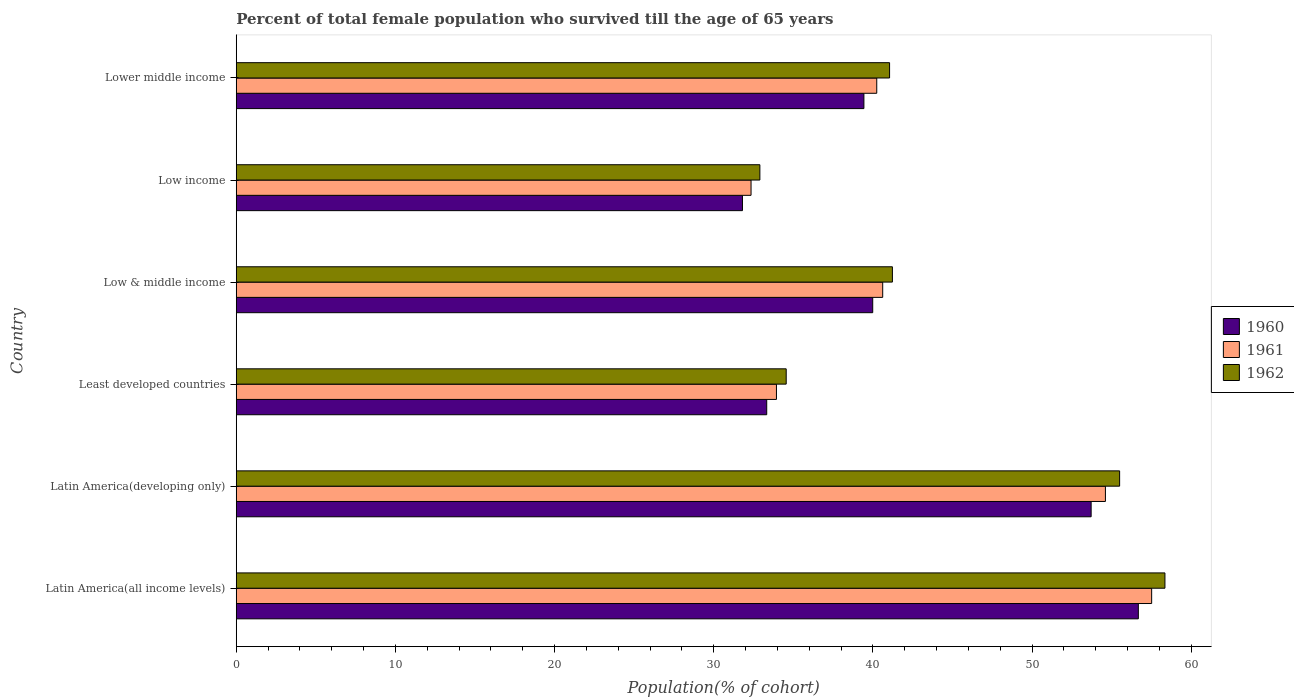How many groups of bars are there?
Provide a succinct answer. 6. Are the number of bars per tick equal to the number of legend labels?
Your answer should be very brief. Yes. How many bars are there on the 4th tick from the top?
Offer a very short reply. 3. How many bars are there on the 3rd tick from the bottom?
Provide a short and direct response. 3. What is the label of the 6th group of bars from the top?
Offer a terse response. Latin America(all income levels). What is the percentage of total female population who survived till the age of 65 years in 1960 in Latin America(developing only)?
Keep it short and to the point. 53.71. Across all countries, what is the maximum percentage of total female population who survived till the age of 65 years in 1962?
Provide a short and direct response. 58.34. Across all countries, what is the minimum percentage of total female population who survived till the age of 65 years in 1960?
Keep it short and to the point. 31.8. In which country was the percentage of total female population who survived till the age of 65 years in 1961 maximum?
Your answer should be very brief. Latin America(all income levels). In which country was the percentage of total female population who survived till the age of 65 years in 1961 minimum?
Make the answer very short. Low income. What is the total percentage of total female population who survived till the age of 65 years in 1962 in the graph?
Your answer should be very brief. 263.55. What is the difference between the percentage of total female population who survived till the age of 65 years in 1962 in Low & middle income and that in Lower middle income?
Your answer should be very brief. 0.18. What is the difference between the percentage of total female population who survived till the age of 65 years in 1961 in Latin America(developing only) and the percentage of total female population who survived till the age of 65 years in 1960 in Low income?
Make the answer very short. 22.8. What is the average percentage of total female population who survived till the age of 65 years in 1960 per country?
Provide a succinct answer. 42.49. What is the difference between the percentage of total female population who survived till the age of 65 years in 1960 and percentage of total female population who survived till the age of 65 years in 1962 in Least developed countries?
Give a very brief answer. -1.22. In how many countries, is the percentage of total female population who survived till the age of 65 years in 1962 greater than 56 %?
Your answer should be very brief. 1. What is the ratio of the percentage of total female population who survived till the age of 65 years in 1961 in Latin America(developing only) to that in Least developed countries?
Ensure brevity in your answer.  1.61. Is the percentage of total female population who survived till the age of 65 years in 1960 in Latin America(developing only) less than that in Low income?
Give a very brief answer. No. What is the difference between the highest and the second highest percentage of total female population who survived till the age of 65 years in 1960?
Make the answer very short. 2.97. What is the difference between the highest and the lowest percentage of total female population who survived till the age of 65 years in 1961?
Ensure brevity in your answer.  25.17. In how many countries, is the percentage of total female population who survived till the age of 65 years in 1961 greater than the average percentage of total female population who survived till the age of 65 years in 1961 taken over all countries?
Provide a succinct answer. 2. Is the sum of the percentage of total female population who survived till the age of 65 years in 1961 in Latin America(all income levels) and Latin America(developing only) greater than the maximum percentage of total female population who survived till the age of 65 years in 1960 across all countries?
Provide a succinct answer. Yes. Is it the case that in every country, the sum of the percentage of total female population who survived till the age of 65 years in 1962 and percentage of total female population who survived till the age of 65 years in 1960 is greater than the percentage of total female population who survived till the age of 65 years in 1961?
Provide a succinct answer. Yes. How many bars are there?
Your answer should be compact. 18. Are all the bars in the graph horizontal?
Give a very brief answer. Yes. How many countries are there in the graph?
Your response must be concise. 6. What is the difference between two consecutive major ticks on the X-axis?
Keep it short and to the point. 10. Are the values on the major ticks of X-axis written in scientific E-notation?
Your answer should be very brief. No. Does the graph contain any zero values?
Make the answer very short. No. How many legend labels are there?
Offer a terse response. 3. How are the legend labels stacked?
Offer a terse response. Vertical. What is the title of the graph?
Your response must be concise. Percent of total female population who survived till the age of 65 years. What is the label or title of the X-axis?
Offer a terse response. Population(% of cohort). What is the label or title of the Y-axis?
Provide a succinct answer. Country. What is the Population(% of cohort) of 1960 in Latin America(all income levels)?
Your answer should be compact. 56.67. What is the Population(% of cohort) in 1961 in Latin America(all income levels)?
Ensure brevity in your answer.  57.51. What is the Population(% of cohort) of 1962 in Latin America(all income levels)?
Your answer should be very brief. 58.34. What is the Population(% of cohort) in 1960 in Latin America(developing only)?
Offer a very short reply. 53.71. What is the Population(% of cohort) of 1961 in Latin America(developing only)?
Keep it short and to the point. 54.6. What is the Population(% of cohort) in 1962 in Latin America(developing only)?
Your answer should be compact. 55.5. What is the Population(% of cohort) in 1960 in Least developed countries?
Give a very brief answer. 33.33. What is the Population(% of cohort) of 1961 in Least developed countries?
Offer a very short reply. 33.94. What is the Population(% of cohort) in 1962 in Least developed countries?
Ensure brevity in your answer.  34.55. What is the Population(% of cohort) of 1960 in Low & middle income?
Keep it short and to the point. 39.98. What is the Population(% of cohort) in 1961 in Low & middle income?
Make the answer very short. 40.61. What is the Population(% of cohort) in 1962 in Low & middle income?
Keep it short and to the point. 41.22. What is the Population(% of cohort) in 1960 in Low income?
Ensure brevity in your answer.  31.8. What is the Population(% of cohort) in 1961 in Low income?
Ensure brevity in your answer.  32.34. What is the Population(% of cohort) of 1962 in Low income?
Your response must be concise. 32.9. What is the Population(% of cohort) in 1960 in Lower middle income?
Offer a terse response. 39.43. What is the Population(% of cohort) in 1961 in Lower middle income?
Your response must be concise. 40.24. What is the Population(% of cohort) in 1962 in Lower middle income?
Provide a short and direct response. 41.04. Across all countries, what is the maximum Population(% of cohort) of 1960?
Your answer should be compact. 56.67. Across all countries, what is the maximum Population(% of cohort) in 1961?
Provide a succinct answer. 57.51. Across all countries, what is the maximum Population(% of cohort) in 1962?
Provide a short and direct response. 58.34. Across all countries, what is the minimum Population(% of cohort) of 1960?
Provide a short and direct response. 31.8. Across all countries, what is the minimum Population(% of cohort) in 1961?
Your response must be concise. 32.34. Across all countries, what is the minimum Population(% of cohort) of 1962?
Ensure brevity in your answer.  32.9. What is the total Population(% of cohort) of 1960 in the graph?
Keep it short and to the point. 254.92. What is the total Population(% of cohort) in 1961 in the graph?
Provide a succinct answer. 259.24. What is the total Population(% of cohort) of 1962 in the graph?
Offer a terse response. 263.55. What is the difference between the Population(% of cohort) in 1960 in Latin America(all income levels) and that in Latin America(developing only)?
Keep it short and to the point. 2.97. What is the difference between the Population(% of cohort) in 1961 in Latin America(all income levels) and that in Latin America(developing only)?
Ensure brevity in your answer.  2.9. What is the difference between the Population(% of cohort) of 1962 in Latin America(all income levels) and that in Latin America(developing only)?
Your response must be concise. 2.85. What is the difference between the Population(% of cohort) of 1960 in Latin America(all income levels) and that in Least developed countries?
Give a very brief answer. 23.35. What is the difference between the Population(% of cohort) in 1961 in Latin America(all income levels) and that in Least developed countries?
Provide a short and direct response. 23.57. What is the difference between the Population(% of cohort) in 1962 in Latin America(all income levels) and that in Least developed countries?
Give a very brief answer. 23.79. What is the difference between the Population(% of cohort) in 1960 in Latin America(all income levels) and that in Low & middle income?
Keep it short and to the point. 16.69. What is the difference between the Population(% of cohort) in 1961 in Latin America(all income levels) and that in Low & middle income?
Ensure brevity in your answer.  16.9. What is the difference between the Population(% of cohort) in 1962 in Latin America(all income levels) and that in Low & middle income?
Provide a succinct answer. 17.12. What is the difference between the Population(% of cohort) of 1960 in Latin America(all income levels) and that in Low income?
Provide a short and direct response. 24.87. What is the difference between the Population(% of cohort) in 1961 in Latin America(all income levels) and that in Low income?
Ensure brevity in your answer.  25.17. What is the difference between the Population(% of cohort) in 1962 in Latin America(all income levels) and that in Low income?
Your response must be concise. 25.45. What is the difference between the Population(% of cohort) in 1960 in Latin America(all income levels) and that in Lower middle income?
Give a very brief answer. 17.24. What is the difference between the Population(% of cohort) in 1961 in Latin America(all income levels) and that in Lower middle income?
Your answer should be compact. 17.27. What is the difference between the Population(% of cohort) of 1962 in Latin America(all income levels) and that in Lower middle income?
Provide a short and direct response. 17.3. What is the difference between the Population(% of cohort) in 1960 in Latin America(developing only) and that in Least developed countries?
Offer a very short reply. 20.38. What is the difference between the Population(% of cohort) of 1961 in Latin America(developing only) and that in Least developed countries?
Keep it short and to the point. 20.67. What is the difference between the Population(% of cohort) of 1962 in Latin America(developing only) and that in Least developed countries?
Make the answer very short. 20.95. What is the difference between the Population(% of cohort) in 1960 in Latin America(developing only) and that in Low & middle income?
Give a very brief answer. 13.72. What is the difference between the Population(% of cohort) in 1961 in Latin America(developing only) and that in Low & middle income?
Your answer should be very brief. 13.99. What is the difference between the Population(% of cohort) in 1962 in Latin America(developing only) and that in Low & middle income?
Provide a succinct answer. 14.27. What is the difference between the Population(% of cohort) in 1960 in Latin America(developing only) and that in Low income?
Provide a succinct answer. 21.9. What is the difference between the Population(% of cohort) in 1961 in Latin America(developing only) and that in Low income?
Make the answer very short. 22.26. What is the difference between the Population(% of cohort) of 1962 in Latin America(developing only) and that in Low income?
Offer a terse response. 22.6. What is the difference between the Population(% of cohort) of 1960 in Latin America(developing only) and that in Lower middle income?
Your answer should be very brief. 14.27. What is the difference between the Population(% of cohort) of 1961 in Latin America(developing only) and that in Lower middle income?
Provide a short and direct response. 14.37. What is the difference between the Population(% of cohort) of 1962 in Latin America(developing only) and that in Lower middle income?
Your answer should be very brief. 14.45. What is the difference between the Population(% of cohort) in 1960 in Least developed countries and that in Low & middle income?
Your response must be concise. -6.66. What is the difference between the Population(% of cohort) of 1961 in Least developed countries and that in Low & middle income?
Offer a very short reply. -6.67. What is the difference between the Population(% of cohort) in 1962 in Least developed countries and that in Low & middle income?
Ensure brevity in your answer.  -6.67. What is the difference between the Population(% of cohort) in 1960 in Least developed countries and that in Low income?
Offer a very short reply. 1.52. What is the difference between the Population(% of cohort) of 1961 in Least developed countries and that in Low income?
Give a very brief answer. 1.6. What is the difference between the Population(% of cohort) of 1962 in Least developed countries and that in Low income?
Provide a succinct answer. 1.65. What is the difference between the Population(% of cohort) in 1960 in Least developed countries and that in Lower middle income?
Offer a terse response. -6.11. What is the difference between the Population(% of cohort) in 1961 in Least developed countries and that in Lower middle income?
Keep it short and to the point. -6.3. What is the difference between the Population(% of cohort) of 1962 in Least developed countries and that in Lower middle income?
Your response must be concise. -6.49. What is the difference between the Population(% of cohort) in 1960 in Low & middle income and that in Low income?
Your answer should be compact. 8.18. What is the difference between the Population(% of cohort) in 1961 in Low & middle income and that in Low income?
Ensure brevity in your answer.  8.27. What is the difference between the Population(% of cohort) in 1962 in Low & middle income and that in Low income?
Your answer should be very brief. 8.33. What is the difference between the Population(% of cohort) in 1960 in Low & middle income and that in Lower middle income?
Keep it short and to the point. 0.55. What is the difference between the Population(% of cohort) in 1961 in Low & middle income and that in Lower middle income?
Provide a succinct answer. 0.37. What is the difference between the Population(% of cohort) of 1962 in Low & middle income and that in Lower middle income?
Ensure brevity in your answer.  0.18. What is the difference between the Population(% of cohort) in 1960 in Low income and that in Lower middle income?
Your response must be concise. -7.63. What is the difference between the Population(% of cohort) of 1961 in Low income and that in Lower middle income?
Your answer should be very brief. -7.9. What is the difference between the Population(% of cohort) of 1962 in Low income and that in Lower middle income?
Ensure brevity in your answer.  -8.15. What is the difference between the Population(% of cohort) of 1960 in Latin America(all income levels) and the Population(% of cohort) of 1961 in Latin America(developing only)?
Offer a terse response. 2.07. What is the difference between the Population(% of cohort) in 1960 in Latin America(all income levels) and the Population(% of cohort) in 1962 in Latin America(developing only)?
Your answer should be very brief. 1.18. What is the difference between the Population(% of cohort) of 1961 in Latin America(all income levels) and the Population(% of cohort) of 1962 in Latin America(developing only)?
Ensure brevity in your answer.  2.01. What is the difference between the Population(% of cohort) in 1960 in Latin America(all income levels) and the Population(% of cohort) in 1961 in Least developed countries?
Offer a very short reply. 22.73. What is the difference between the Population(% of cohort) in 1960 in Latin America(all income levels) and the Population(% of cohort) in 1962 in Least developed countries?
Provide a succinct answer. 22.12. What is the difference between the Population(% of cohort) in 1961 in Latin America(all income levels) and the Population(% of cohort) in 1962 in Least developed countries?
Provide a short and direct response. 22.96. What is the difference between the Population(% of cohort) of 1960 in Latin America(all income levels) and the Population(% of cohort) of 1961 in Low & middle income?
Offer a terse response. 16.06. What is the difference between the Population(% of cohort) in 1960 in Latin America(all income levels) and the Population(% of cohort) in 1962 in Low & middle income?
Your answer should be very brief. 15.45. What is the difference between the Population(% of cohort) in 1961 in Latin America(all income levels) and the Population(% of cohort) in 1962 in Low & middle income?
Your response must be concise. 16.29. What is the difference between the Population(% of cohort) of 1960 in Latin America(all income levels) and the Population(% of cohort) of 1961 in Low income?
Keep it short and to the point. 24.33. What is the difference between the Population(% of cohort) in 1960 in Latin America(all income levels) and the Population(% of cohort) in 1962 in Low income?
Offer a terse response. 23.78. What is the difference between the Population(% of cohort) in 1961 in Latin America(all income levels) and the Population(% of cohort) in 1962 in Low income?
Provide a succinct answer. 24.61. What is the difference between the Population(% of cohort) in 1960 in Latin America(all income levels) and the Population(% of cohort) in 1961 in Lower middle income?
Your response must be concise. 16.43. What is the difference between the Population(% of cohort) in 1960 in Latin America(all income levels) and the Population(% of cohort) in 1962 in Lower middle income?
Provide a short and direct response. 15.63. What is the difference between the Population(% of cohort) of 1961 in Latin America(all income levels) and the Population(% of cohort) of 1962 in Lower middle income?
Provide a short and direct response. 16.46. What is the difference between the Population(% of cohort) of 1960 in Latin America(developing only) and the Population(% of cohort) of 1961 in Least developed countries?
Make the answer very short. 19.77. What is the difference between the Population(% of cohort) in 1960 in Latin America(developing only) and the Population(% of cohort) in 1962 in Least developed countries?
Make the answer very short. 19.16. What is the difference between the Population(% of cohort) of 1961 in Latin America(developing only) and the Population(% of cohort) of 1962 in Least developed countries?
Offer a very short reply. 20.05. What is the difference between the Population(% of cohort) in 1960 in Latin America(developing only) and the Population(% of cohort) in 1961 in Low & middle income?
Your answer should be compact. 13.09. What is the difference between the Population(% of cohort) of 1960 in Latin America(developing only) and the Population(% of cohort) of 1962 in Low & middle income?
Provide a succinct answer. 12.48. What is the difference between the Population(% of cohort) in 1961 in Latin America(developing only) and the Population(% of cohort) in 1962 in Low & middle income?
Keep it short and to the point. 13.38. What is the difference between the Population(% of cohort) of 1960 in Latin America(developing only) and the Population(% of cohort) of 1961 in Low income?
Make the answer very short. 21.36. What is the difference between the Population(% of cohort) in 1960 in Latin America(developing only) and the Population(% of cohort) in 1962 in Low income?
Your answer should be very brief. 20.81. What is the difference between the Population(% of cohort) in 1961 in Latin America(developing only) and the Population(% of cohort) in 1962 in Low income?
Your response must be concise. 21.71. What is the difference between the Population(% of cohort) of 1960 in Latin America(developing only) and the Population(% of cohort) of 1961 in Lower middle income?
Your response must be concise. 13.47. What is the difference between the Population(% of cohort) in 1960 in Latin America(developing only) and the Population(% of cohort) in 1962 in Lower middle income?
Ensure brevity in your answer.  12.66. What is the difference between the Population(% of cohort) in 1961 in Latin America(developing only) and the Population(% of cohort) in 1962 in Lower middle income?
Your answer should be very brief. 13.56. What is the difference between the Population(% of cohort) of 1960 in Least developed countries and the Population(% of cohort) of 1961 in Low & middle income?
Your response must be concise. -7.29. What is the difference between the Population(% of cohort) of 1960 in Least developed countries and the Population(% of cohort) of 1962 in Low & middle income?
Keep it short and to the point. -7.9. What is the difference between the Population(% of cohort) in 1961 in Least developed countries and the Population(% of cohort) in 1962 in Low & middle income?
Ensure brevity in your answer.  -7.28. What is the difference between the Population(% of cohort) of 1960 in Least developed countries and the Population(% of cohort) of 1961 in Low income?
Provide a succinct answer. 0.98. What is the difference between the Population(% of cohort) in 1960 in Least developed countries and the Population(% of cohort) in 1962 in Low income?
Offer a terse response. 0.43. What is the difference between the Population(% of cohort) in 1961 in Least developed countries and the Population(% of cohort) in 1962 in Low income?
Ensure brevity in your answer.  1.04. What is the difference between the Population(% of cohort) in 1960 in Least developed countries and the Population(% of cohort) in 1961 in Lower middle income?
Your response must be concise. -6.91. What is the difference between the Population(% of cohort) of 1960 in Least developed countries and the Population(% of cohort) of 1962 in Lower middle income?
Your answer should be compact. -7.72. What is the difference between the Population(% of cohort) in 1961 in Least developed countries and the Population(% of cohort) in 1962 in Lower middle income?
Make the answer very short. -7.11. What is the difference between the Population(% of cohort) in 1960 in Low & middle income and the Population(% of cohort) in 1961 in Low income?
Your answer should be compact. 7.64. What is the difference between the Population(% of cohort) of 1960 in Low & middle income and the Population(% of cohort) of 1962 in Low income?
Provide a succinct answer. 7.09. What is the difference between the Population(% of cohort) of 1961 in Low & middle income and the Population(% of cohort) of 1962 in Low income?
Offer a terse response. 7.72. What is the difference between the Population(% of cohort) in 1960 in Low & middle income and the Population(% of cohort) in 1961 in Lower middle income?
Offer a terse response. -0.25. What is the difference between the Population(% of cohort) in 1960 in Low & middle income and the Population(% of cohort) in 1962 in Lower middle income?
Your response must be concise. -1.06. What is the difference between the Population(% of cohort) in 1961 in Low & middle income and the Population(% of cohort) in 1962 in Lower middle income?
Offer a very short reply. -0.43. What is the difference between the Population(% of cohort) in 1960 in Low income and the Population(% of cohort) in 1961 in Lower middle income?
Ensure brevity in your answer.  -8.44. What is the difference between the Population(% of cohort) of 1960 in Low income and the Population(% of cohort) of 1962 in Lower middle income?
Give a very brief answer. -9.24. What is the difference between the Population(% of cohort) of 1961 in Low income and the Population(% of cohort) of 1962 in Lower middle income?
Provide a succinct answer. -8.7. What is the average Population(% of cohort) in 1960 per country?
Provide a succinct answer. 42.49. What is the average Population(% of cohort) in 1961 per country?
Your answer should be compact. 43.21. What is the average Population(% of cohort) in 1962 per country?
Provide a short and direct response. 43.92. What is the difference between the Population(% of cohort) in 1960 and Population(% of cohort) in 1961 in Latin America(all income levels)?
Offer a terse response. -0.84. What is the difference between the Population(% of cohort) of 1960 and Population(% of cohort) of 1962 in Latin America(all income levels)?
Make the answer very short. -1.67. What is the difference between the Population(% of cohort) in 1961 and Population(% of cohort) in 1962 in Latin America(all income levels)?
Offer a very short reply. -0.83. What is the difference between the Population(% of cohort) in 1960 and Population(% of cohort) in 1961 in Latin America(developing only)?
Make the answer very short. -0.9. What is the difference between the Population(% of cohort) in 1960 and Population(% of cohort) in 1962 in Latin America(developing only)?
Your answer should be compact. -1.79. What is the difference between the Population(% of cohort) in 1961 and Population(% of cohort) in 1962 in Latin America(developing only)?
Your answer should be compact. -0.89. What is the difference between the Population(% of cohort) of 1960 and Population(% of cohort) of 1961 in Least developed countries?
Ensure brevity in your answer.  -0.61. What is the difference between the Population(% of cohort) of 1960 and Population(% of cohort) of 1962 in Least developed countries?
Ensure brevity in your answer.  -1.22. What is the difference between the Population(% of cohort) of 1961 and Population(% of cohort) of 1962 in Least developed countries?
Your answer should be very brief. -0.61. What is the difference between the Population(% of cohort) of 1960 and Population(% of cohort) of 1961 in Low & middle income?
Give a very brief answer. -0.63. What is the difference between the Population(% of cohort) in 1960 and Population(% of cohort) in 1962 in Low & middle income?
Ensure brevity in your answer.  -1.24. What is the difference between the Population(% of cohort) of 1961 and Population(% of cohort) of 1962 in Low & middle income?
Make the answer very short. -0.61. What is the difference between the Population(% of cohort) in 1960 and Population(% of cohort) in 1961 in Low income?
Provide a succinct answer. -0.54. What is the difference between the Population(% of cohort) of 1960 and Population(% of cohort) of 1962 in Low income?
Make the answer very short. -1.09. What is the difference between the Population(% of cohort) in 1961 and Population(% of cohort) in 1962 in Low income?
Your response must be concise. -0.55. What is the difference between the Population(% of cohort) in 1960 and Population(% of cohort) in 1961 in Lower middle income?
Your response must be concise. -0.81. What is the difference between the Population(% of cohort) of 1960 and Population(% of cohort) of 1962 in Lower middle income?
Offer a terse response. -1.61. What is the difference between the Population(% of cohort) of 1961 and Population(% of cohort) of 1962 in Lower middle income?
Make the answer very short. -0.81. What is the ratio of the Population(% of cohort) of 1960 in Latin America(all income levels) to that in Latin America(developing only)?
Your response must be concise. 1.06. What is the ratio of the Population(% of cohort) in 1961 in Latin America(all income levels) to that in Latin America(developing only)?
Your answer should be very brief. 1.05. What is the ratio of the Population(% of cohort) in 1962 in Latin America(all income levels) to that in Latin America(developing only)?
Provide a short and direct response. 1.05. What is the ratio of the Population(% of cohort) in 1960 in Latin America(all income levels) to that in Least developed countries?
Offer a terse response. 1.7. What is the ratio of the Population(% of cohort) of 1961 in Latin America(all income levels) to that in Least developed countries?
Keep it short and to the point. 1.69. What is the ratio of the Population(% of cohort) in 1962 in Latin America(all income levels) to that in Least developed countries?
Your answer should be compact. 1.69. What is the ratio of the Population(% of cohort) of 1960 in Latin America(all income levels) to that in Low & middle income?
Offer a very short reply. 1.42. What is the ratio of the Population(% of cohort) of 1961 in Latin America(all income levels) to that in Low & middle income?
Make the answer very short. 1.42. What is the ratio of the Population(% of cohort) in 1962 in Latin America(all income levels) to that in Low & middle income?
Keep it short and to the point. 1.42. What is the ratio of the Population(% of cohort) in 1960 in Latin America(all income levels) to that in Low income?
Make the answer very short. 1.78. What is the ratio of the Population(% of cohort) of 1961 in Latin America(all income levels) to that in Low income?
Your answer should be very brief. 1.78. What is the ratio of the Population(% of cohort) in 1962 in Latin America(all income levels) to that in Low income?
Your answer should be very brief. 1.77. What is the ratio of the Population(% of cohort) of 1960 in Latin America(all income levels) to that in Lower middle income?
Give a very brief answer. 1.44. What is the ratio of the Population(% of cohort) in 1961 in Latin America(all income levels) to that in Lower middle income?
Provide a succinct answer. 1.43. What is the ratio of the Population(% of cohort) in 1962 in Latin America(all income levels) to that in Lower middle income?
Give a very brief answer. 1.42. What is the ratio of the Population(% of cohort) in 1960 in Latin America(developing only) to that in Least developed countries?
Your answer should be very brief. 1.61. What is the ratio of the Population(% of cohort) in 1961 in Latin America(developing only) to that in Least developed countries?
Provide a succinct answer. 1.61. What is the ratio of the Population(% of cohort) of 1962 in Latin America(developing only) to that in Least developed countries?
Provide a succinct answer. 1.61. What is the ratio of the Population(% of cohort) of 1960 in Latin America(developing only) to that in Low & middle income?
Offer a terse response. 1.34. What is the ratio of the Population(% of cohort) in 1961 in Latin America(developing only) to that in Low & middle income?
Your answer should be compact. 1.34. What is the ratio of the Population(% of cohort) in 1962 in Latin America(developing only) to that in Low & middle income?
Give a very brief answer. 1.35. What is the ratio of the Population(% of cohort) of 1960 in Latin America(developing only) to that in Low income?
Keep it short and to the point. 1.69. What is the ratio of the Population(% of cohort) in 1961 in Latin America(developing only) to that in Low income?
Offer a terse response. 1.69. What is the ratio of the Population(% of cohort) in 1962 in Latin America(developing only) to that in Low income?
Provide a short and direct response. 1.69. What is the ratio of the Population(% of cohort) of 1960 in Latin America(developing only) to that in Lower middle income?
Keep it short and to the point. 1.36. What is the ratio of the Population(% of cohort) in 1961 in Latin America(developing only) to that in Lower middle income?
Your answer should be compact. 1.36. What is the ratio of the Population(% of cohort) in 1962 in Latin America(developing only) to that in Lower middle income?
Provide a succinct answer. 1.35. What is the ratio of the Population(% of cohort) of 1960 in Least developed countries to that in Low & middle income?
Provide a succinct answer. 0.83. What is the ratio of the Population(% of cohort) of 1961 in Least developed countries to that in Low & middle income?
Provide a succinct answer. 0.84. What is the ratio of the Population(% of cohort) in 1962 in Least developed countries to that in Low & middle income?
Offer a terse response. 0.84. What is the ratio of the Population(% of cohort) of 1960 in Least developed countries to that in Low income?
Offer a terse response. 1.05. What is the ratio of the Population(% of cohort) in 1961 in Least developed countries to that in Low income?
Your answer should be compact. 1.05. What is the ratio of the Population(% of cohort) of 1962 in Least developed countries to that in Low income?
Provide a short and direct response. 1.05. What is the ratio of the Population(% of cohort) of 1960 in Least developed countries to that in Lower middle income?
Offer a terse response. 0.85. What is the ratio of the Population(% of cohort) of 1961 in Least developed countries to that in Lower middle income?
Give a very brief answer. 0.84. What is the ratio of the Population(% of cohort) in 1962 in Least developed countries to that in Lower middle income?
Your answer should be very brief. 0.84. What is the ratio of the Population(% of cohort) of 1960 in Low & middle income to that in Low income?
Keep it short and to the point. 1.26. What is the ratio of the Population(% of cohort) of 1961 in Low & middle income to that in Low income?
Your answer should be very brief. 1.26. What is the ratio of the Population(% of cohort) of 1962 in Low & middle income to that in Low income?
Your answer should be compact. 1.25. What is the ratio of the Population(% of cohort) of 1961 in Low & middle income to that in Lower middle income?
Ensure brevity in your answer.  1.01. What is the ratio of the Population(% of cohort) of 1962 in Low & middle income to that in Lower middle income?
Ensure brevity in your answer.  1. What is the ratio of the Population(% of cohort) in 1960 in Low income to that in Lower middle income?
Provide a short and direct response. 0.81. What is the ratio of the Population(% of cohort) in 1961 in Low income to that in Lower middle income?
Your answer should be compact. 0.8. What is the ratio of the Population(% of cohort) in 1962 in Low income to that in Lower middle income?
Offer a terse response. 0.8. What is the difference between the highest and the second highest Population(% of cohort) of 1960?
Provide a succinct answer. 2.97. What is the difference between the highest and the second highest Population(% of cohort) of 1961?
Your answer should be compact. 2.9. What is the difference between the highest and the second highest Population(% of cohort) of 1962?
Your answer should be compact. 2.85. What is the difference between the highest and the lowest Population(% of cohort) in 1960?
Your response must be concise. 24.87. What is the difference between the highest and the lowest Population(% of cohort) in 1961?
Make the answer very short. 25.17. What is the difference between the highest and the lowest Population(% of cohort) in 1962?
Your answer should be compact. 25.45. 